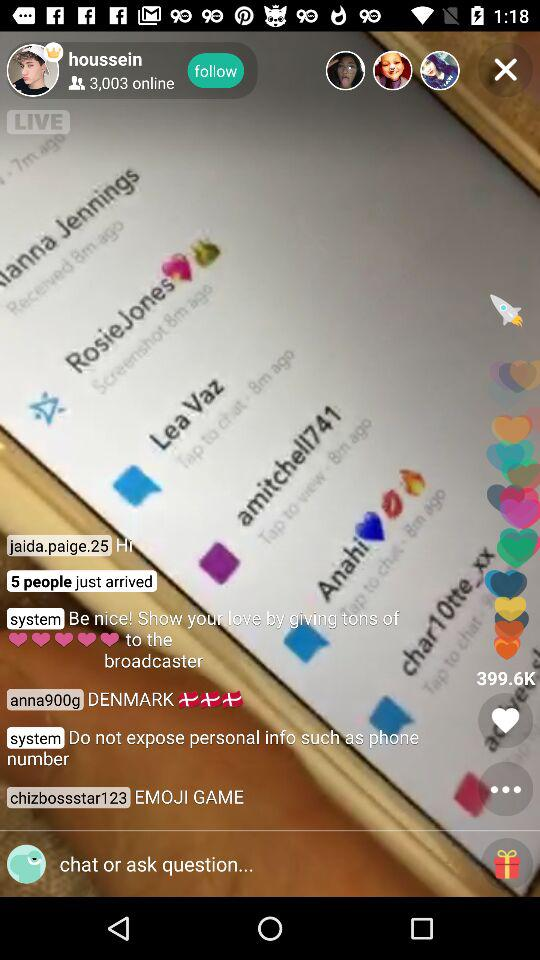How many people have just arrived? The number of people who have just arrived is 5. 